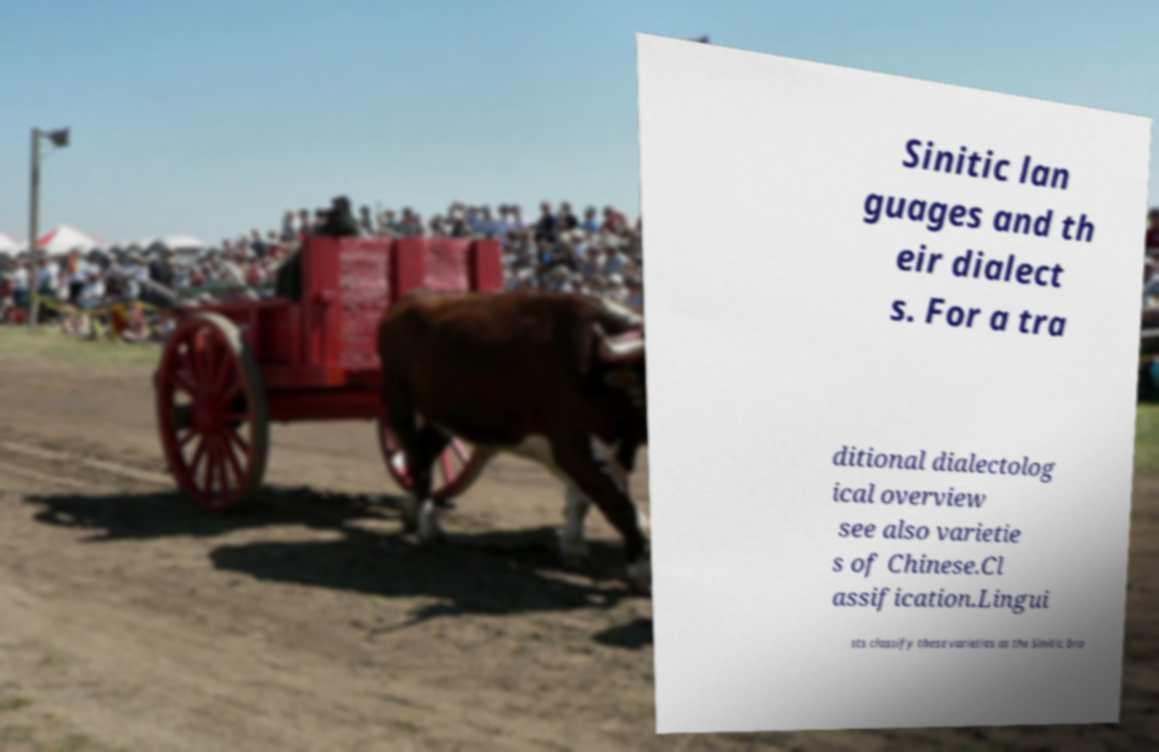There's text embedded in this image that I need extracted. Can you transcribe it verbatim? Sinitic lan guages and th eir dialect s. For a tra ditional dialectolog ical overview see also varietie s of Chinese.Cl assification.Lingui sts classify these varieties as the Sinitic bra 